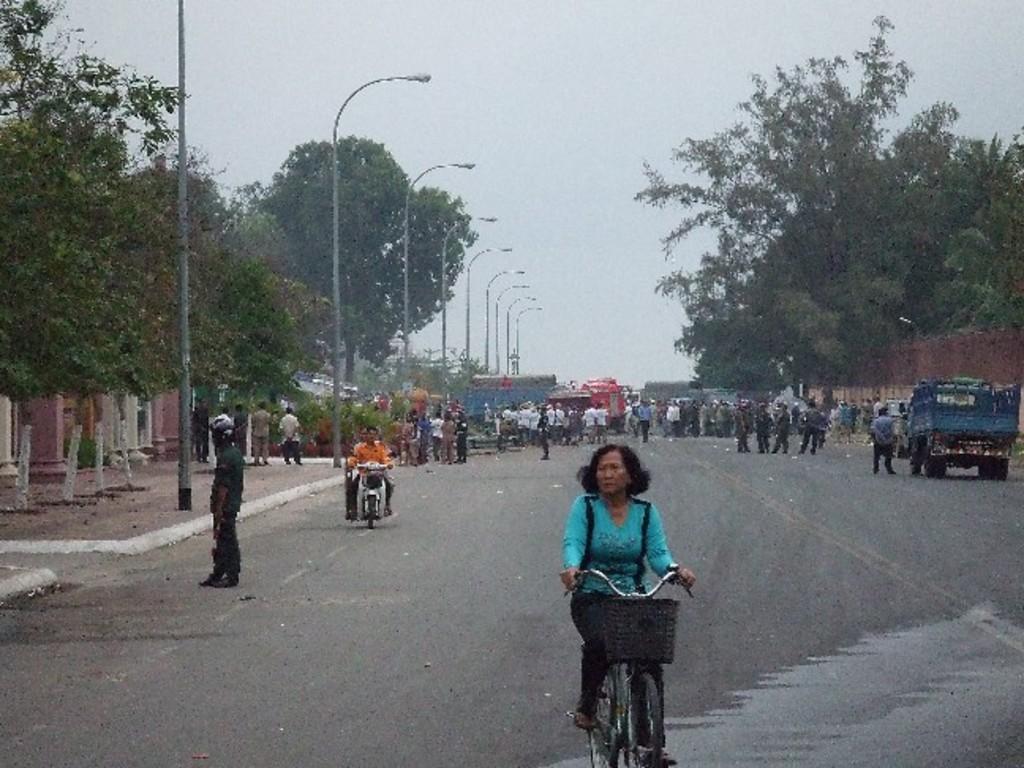How would you summarize this image in a sentence or two? In this image we can see a woman wearing blue dress is riding a bicycle on the road. In the background of the image we can see many people, trees, street lights and vehicles on the road. 